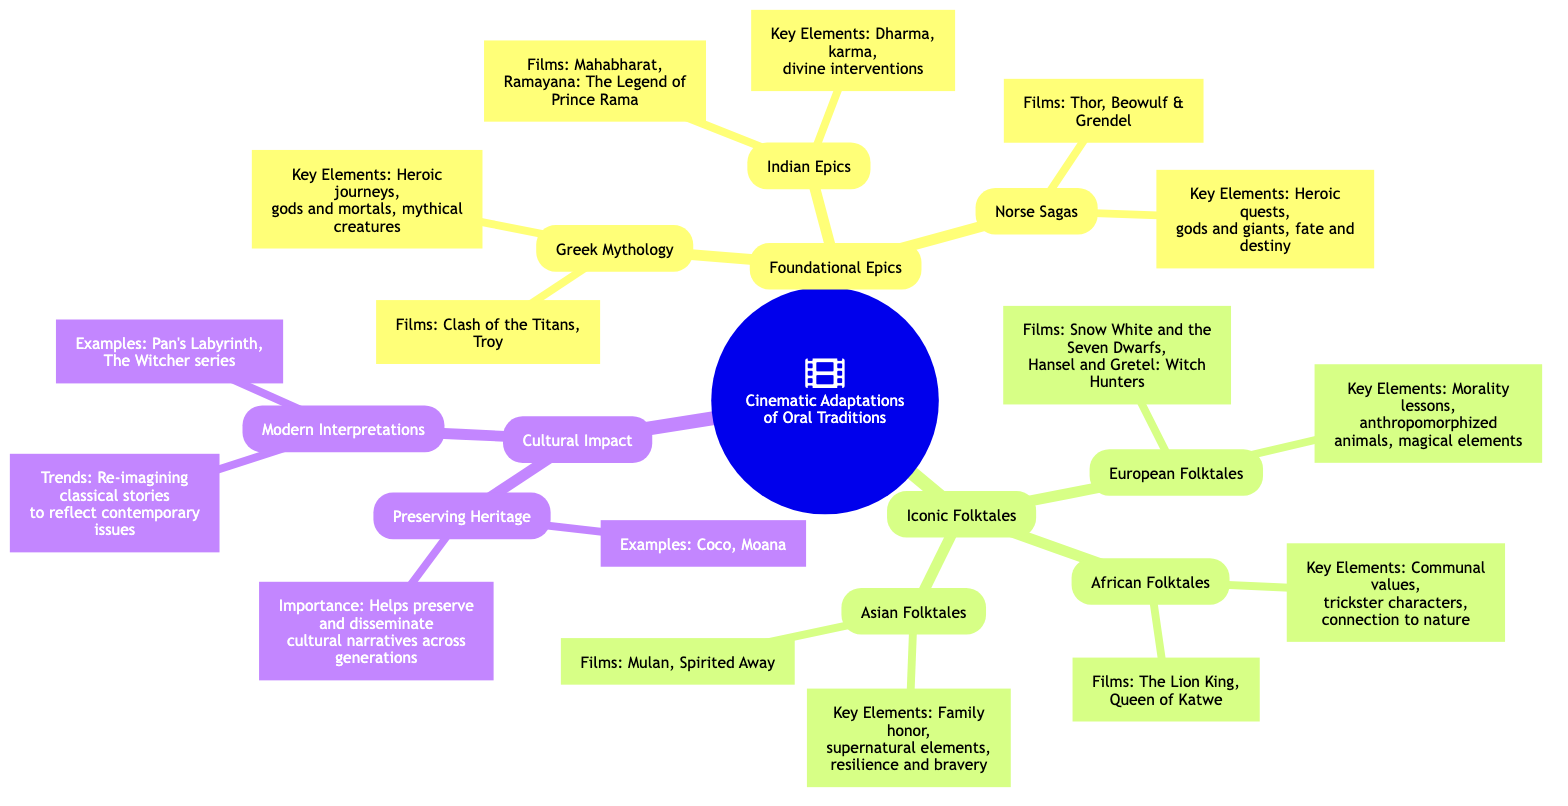What are the three main categories of cinematic adaptations listed? The diagram lists three main categories: Foundational Epics, Iconic Folktales, and Cultural Impact.
Answer: Foundational Epics, Iconic Folktales, Cultural Impact Which Greek mythology films are mentioned? The subbranch under Greek Mythology lists two films: 'Clash of the Titans' and 'Troy'.
Answer: Clash of the Titans, Troy What key elements are associated with Indian Epics? The details under Indian Epics state key elements like Dharma, karma, and divine interventions.
Answer: Dharma, karma, divine interventions How many subbranches are under Iconic Folktales? The Iconic Folktales branch has three subbranches: European Folktales, African Folktales, and Asian Folktales.
Answer: 3 Which film is cited as an example of preserving heritage? Under Preserving Heritage, 'Coco' is provided as an example of preserving cultural narratives.
Answer: Coco What is a trend listed under Modern Interpretations? The Modern Interpretations subbranch states a trend of re-imagining classical stories to reflect contemporary issues.
Answer: Re-imagining classical stories Which iconic folktale films focus on African narratives? The African Folktales subbranch lists 'The Lion King' and 'Queen of Katwe' as films.
Answer: The Lion King, Queen of Katwe How do the key elements of Asian Folktales primarily characterize family dynamics? The key elements of Asian Folktales emphasize family honor, supernatural elements, and bravery, highlighting the importance of familial relationships.
Answer: Family honor What are some examples of modern adaptations mentioned in the diagram? The Modern Interpretations subbranch provides two examples: 'Pan's Labyrinth' and 'The Witcher' series.
Answer: Pan's Labyrinth, The Witcher series 